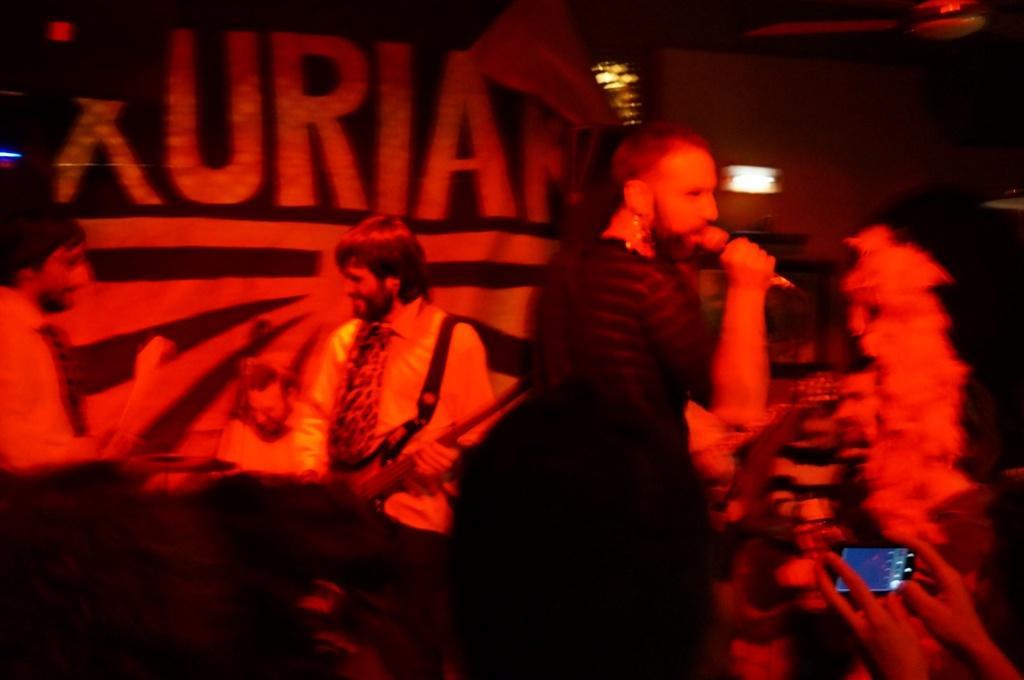Please provide a concise description of this image. In this image there are a group of people and in the center there is one person who is holding a mike and singing, and at the bottom there is one person who is holding a mobile. In the background there are some people who are holding some musical instruments, and also there are some lights and some other objects. 